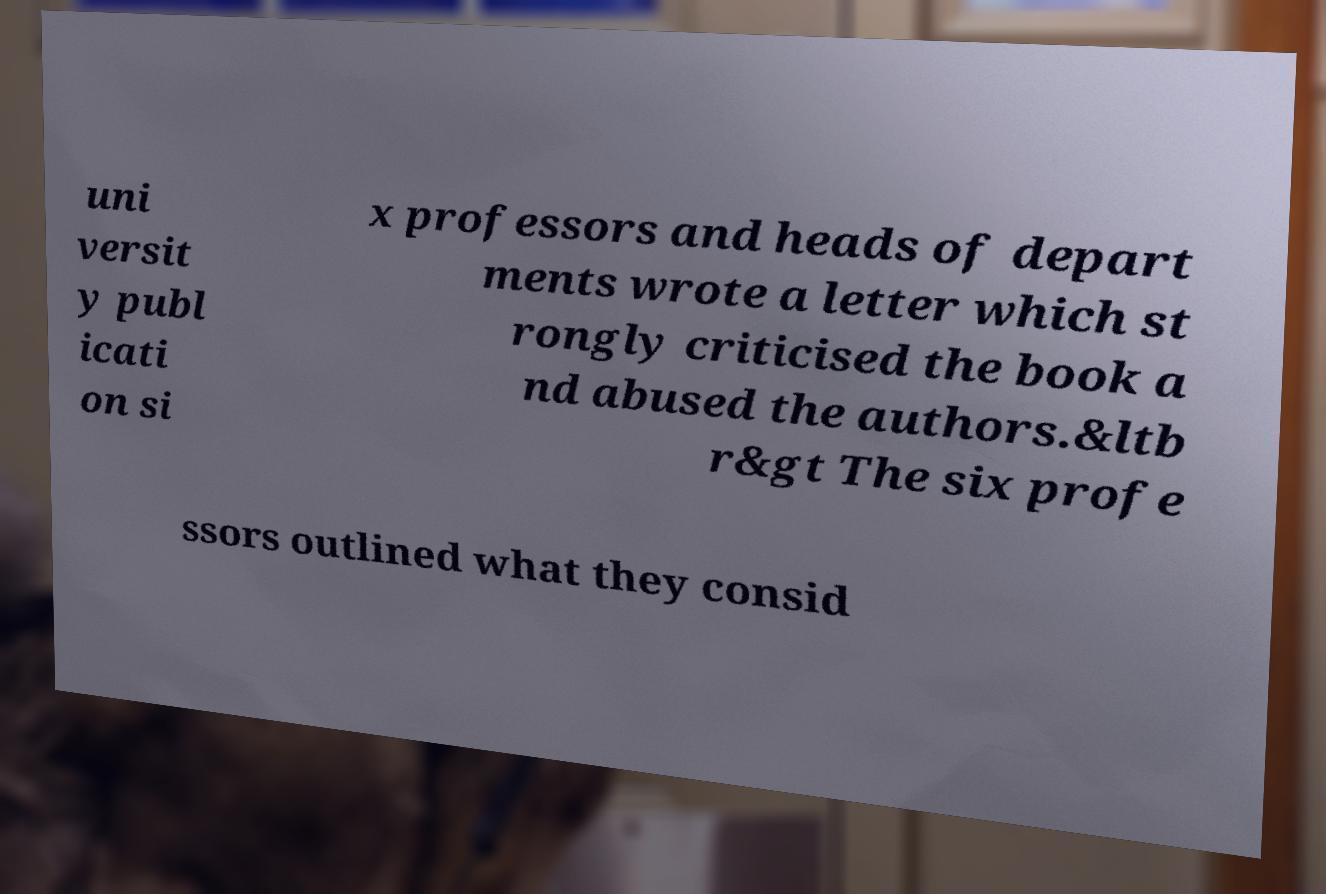What messages or text are displayed in this image? I need them in a readable, typed format. uni versit y publ icati on si x professors and heads of depart ments wrote a letter which st rongly criticised the book a nd abused the authors.&ltb r&gt The six profe ssors outlined what they consid 